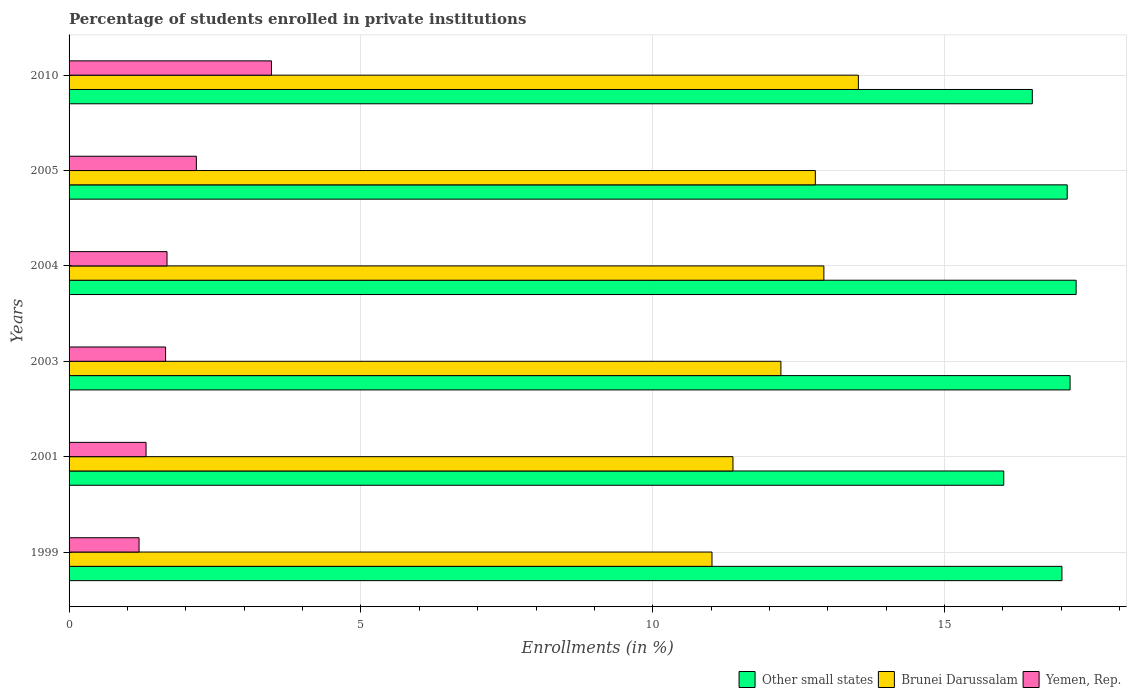How many groups of bars are there?
Your answer should be compact. 6. How many bars are there on the 4th tick from the top?
Keep it short and to the point. 3. How many bars are there on the 5th tick from the bottom?
Offer a terse response. 3. What is the label of the 1st group of bars from the top?
Offer a terse response. 2010. What is the percentage of trained teachers in Brunei Darussalam in 2005?
Provide a succinct answer. 12.79. Across all years, what is the maximum percentage of trained teachers in Other small states?
Provide a short and direct response. 17.25. Across all years, what is the minimum percentage of trained teachers in Brunei Darussalam?
Make the answer very short. 11.01. In which year was the percentage of trained teachers in Yemen, Rep. minimum?
Give a very brief answer. 1999. What is the total percentage of trained teachers in Brunei Darussalam in the graph?
Make the answer very short. 73.83. What is the difference between the percentage of trained teachers in Brunei Darussalam in 1999 and that in 2003?
Offer a terse response. -1.18. What is the difference between the percentage of trained teachers in Other small states in 1999 and the percentage of trained teachers in Brunei Darussalam in 2003?
Your answer should be very brief. 4.81. What is the average percentage of trained teachers in Yemen, Rep. per year?
Provide a succinct answer. 1.92. In the year 2010, what is the difference between the percentage of trained teachers in Yemen, Rep. and percentage of trained teachers in Other small states?
Provide a succinct answer. -13.04. What is the ratio of the percentage of trained teachers in Brunei Darussalam in 2001 to that in 2003?
Give a very brief answer. 0.93. Is the percentage of trained teachers in Other small states in 1999 less than that in 2003?
Offer a very short reply. Yes. Is the difference between the percentage of trained teachers in Yemen, Rep. in 2003 and 2005 greater than the difference between the percentage of trained teachers in Other small states in 2003 and 2005?
Make the answer very short. No. What is the difference between the highest and the second highest percentage of trained teachers in Brunei Darussalam?
Give a very brief answer. 0.59. What is the difference between the highest and the lowest percentage of trained teachers in Yemen, Rep.?
Ensure brevity in your answer.  2.27. In how many years, is the percentage of trained teachers in Yemen, Rep. greater than the average percentage of trained teachers in Yemen, Rep. taken over all years?
Offer a terse response. 2. What does the 1st bar from the top in 1999 represents?
Provide a succinct answer. Yemen, Rep. What does the 3rd bar from the bottom in 1999 represents?
Give a very brief answer. Yemen, Rep. How many bars are there?
Your answer should be compact. 18. What is the difference between two consecutive major ticks on the X-axis?
Provide a short and direct response. 5. Does the graph contain any zero values?
Provide a succinct answer. No. How are the legend labels stacked?
Your answer should be very brief. Horizontal. What is the title of the graph?
Ensure brevity in your answer.  Percentage of students enrolled in private institutions. What is the label or title of the X-axis?
Ensure brevity in your answer.  Enrollments (in %). What is the label or title of the Y-axis?
Make the answer very short. Years. What is the Enrollments (in %) in Other small states in 1999?
Your response must be concise. 17.01. What is the Enrollments (in %) in Brunei Darussalam in 1999?
Ensure brevity in your answer.  11.01. What is the Enrollments (in %) in Yemen, Rep. in 1999?
Offer a very short reply. 1.2. What is the Enrollments (in %) of Other small states in 2001?
Give a very brief answer. 16.01. What is the Enrollments (in %) of Brunei Darussalam in 2001?
Your answer should be very brief. 11.37. What is the Enrollments (in %) in Yemen, Rep. in 2001?
Give a very brief answer. 1.32. What is the Enrollments (in %) of Other small states in 2003?
Your response must be concise. 17.15. What is the Enrollments (in %) of Brunei Darussalam in 2003?
Offer a very short reply. 12.2. What is the Enrollments (in %) of Yemen, Rep. in 2003?
Offer a very short reply. 1.65. What is the Enrollments (in %) of Other small states in 2004?
Offer a very short reply. 17.25. What is the Enrollments (in %) in Brunei Darussalam in 2004?
Offer a very short reply. 12.93. What is the Enrollments (in %) in Yemen, Rep. in 2004?
Your response must be concise. 1.68. What is the Enrollments (in %) in Other small states in 2005?
Offer a terse response. 17.1. What is the Enrollments (in %) in Brunei Darussalam in 2005?
Offer a very short reply. 12.79. What is the Enrollments (in %) of Yemen, Rep. in 2005?
Make the answer very short. 2.18. What is the Enrollments (in %) in Other small states in 2010?
Provide a succinct answer. 16.5. What is the Enrollments (in %) of Brunei Darussalam in 2010?
Provide a short and direct response. 13.52. What is the Enrollments (in %) in Yemen, Rep. in 2010?
Your answer should be compact. 3.47. Across all years, what is the maximum Enrollments (in %) of Other small states?
Provide a succinct answer. 17.25. Across all years, what is the maximum Enrollments (in %) in Brunei Darussalam?
Keep it short and to the point. 13.52. Across all years, what is the maximum Enrollments (in %) of Yemen, Rep.?
Offer a terse response. 3.47. Across all years, what is the minimum Enrollments (in %) in Other small states?
Keep it short and to the point. 16.01. Across all years, what is the minimum Enrollments (in %) of Brunei Darussalam?
Your response must be concise. 11.01. Across all years, what is the minimum Enrollments (in %) in Yemen, Rep.?
Your answer should be very brief. 1.2. What is the total Enrollments (in %) of Other small states in the graph?
Offer a very short reply. 101.03. What is the total Enrollments (in %) in Brunei Darussalam in the graph?
Ensure brevity in your answer.  73.83. What is the total Enrollments (in %) in Yemen, Rep. in the graph?
Provide a succinct answer. 11.5. What is the difference between the Enrollments (in %) in Brunei Darussalam in 1999 and that in 2001?
Provide a short and direct response. -0.36. What is the difference between the Enrollments (in %) of Yemen, Rep. in 1999 and that in 2001?
Ensure brevity in your answer.  -0.12. What is the difference between the Enrollments (in %) of Other small states in 1999 and that in 2003?
Keep it short and to the point. -0.14. What is the difference between the Enrollments (in %) in Brunei Darussalam in 1999 and that in 2003?
Offer a terse response. -1.18. What is the difference between the Enrollments (in %) of Yemen, Rep. in 1999 and that in 2003?
Provide a succinct answer. -0.45. What is the difference between the Enrollments (in %) of Other small states in 1999 and that in 2004?
Your answer should be compact. -0.24. What is the difference between the Enrollments (in %) in Brunei Darussalam in 1999 and that in 2004?
Offer a terse response. -1.92. What is the difference between the Enrollments (in %) of Yemen, Rep. in 1999 and that in 2004?
Give a very brief answer. -0.48. What is the difference between the Enrollments (in %) in Other small states in 1999 and that in 2005?
Ensure brevity in your answer.  -0.09. What is the difference between the Enrollments (in %) in Brunei Darussalam in 1999 and that in 2005?
Ensure brevity in your answer.  -1.77. What is the difference between the Enrollments (in %) in Yemen, Rep. in 1999 and that in 2005?
Give a very brief answer. -0.98. What is the difference between the Enrollments (in %) in Other small states in 1999 and that in 2010?
Give a very brief answer. 0.51. What is the difference between the Enrollments (in %) of Brunei Darussalam in 1999 and that in 2010?
Give a very brief answer. -2.51. What is the difference between the Enrollments (in %) of Yemen, Rep. in 1999 and that in 2010?
Offer a very short reply. -2.27. What is the difference between the Enrollments (in %) of Other small states in 2001 and that in 2003?
Keep it short and to the point. -1.14. What is the difference between the Enrollments (in %) in Brunei Darussalam in 2001 and that in 2003?
Offer a very short reply. -0.82. What is the difference between the Enrollments (in %) in Yemen, Rep. in 2001 and that in 2003?
Your answer should be very brief. -0.33. What is the difference between the Enrollments (in %) in Other small states in 2001 and that in 2004?
Ensure brevity in your answer.  -1.24. What is the difference between the Enrollments (in %) in Brunei Darussalam in 2001 and that in 2004?
Offer a very short reply. -1.56. What is the difference between the Enrollments (in %) of Yemen, Rep. in 2001 and that in 2004?
Make the answer very short. -0.36. What is the difference between the Enrollments (in %) of Other small states in 2001 and that in 2005?
Your answer should be compact. -1.09. What is the difference between the Enrollments (in %) in Brunei Darussalam in 2001 and that in 2005?
Make the answer very short. -1.41. What is the difference between the Enrollments (in %) in Yemen, Rep. in 2001 and that in 2005?
Offer a very short reply. -0.86. What is the difference between the Enrollments (in %) of Other small states in 2001 and that in 2010?
Offer a very short reply. -0.49. What is the difference between the Enrollments (in %) of Brunei Darussalam in 2001 and that in 2010?
Ensure brevity in your answer.  -2.15. What is the difference between the Enrollments (in %) of Yemen, Rep. in 2001 and that in 2010?
Your response must be concise. -2.15. What is the difference between the Enrollments (in %) of Other small states in 2003 and that in 2004?
Provide a succinct answer. -0.1. What is the difference between the Enrollments (in %) in Brunei Darussalam in 2003 and that in 2004?
Your response must be concise. -0.74. What is the difference between the Enrollments (in %) of Yemen, Rep. in 2003 and that in 2004?
Offer a terse response. -0.02. What is the difference between the Enrollments (in %) of Other small states in 2003 and that in 2005?
Provide a short and direct response. 0.05. What is the difference between the Enrollments (in %) of Brunei Darussalam in 2003 and that in 2005?
Your answer should be compact. -0.59. What is the difference between the Enrollments (in %) of Yemen, Rep. in 2003 and that in 2005?
Offer a terse response. -0.53. What is the difference between the Enrollments (in %) in Other small states in 2003 and that in 2010?
Offer a terse response. 0.65. What is the difference between the Enrollments (in %) in Brunei Darussalam in 2003 and that in 2010?
Your response must be concise. -1.33. What is the difference between the Enrollments (in %) in Yemen, Rep. in 2003 and that in 2010?
Give a very brief answer. -1.81. What is the difference between the Enrollments (in %) of Other small states in 2004 and that in 2005?
Offer a terse response. 0.15. What is the difference between the Enrollments (in %) of Brunei Darussalam in 2004 and that in 2005?
Make the answer very short. 0.15. What is the difference between the Enrollments (in %) of Yemen, Rep. in 2004 and that in 2005?
Your response must be concise. -0.5. What is the difference between the Enrollments (in %) in Other small states in 2004 and that in 2010?
Your answer should be compact. 0.75. What is the difference between the Enrollments (in %) in Brunei Darussalam in 2004 and that in 2010?
Keep it short and to the point. -0.59. What is the difference between the Enrollments (in %) in Yemen, Rep. in 2004 and that in 2010?
Keep it short and to the point. -1.79. What is the difference between the Enrollments (in %) in Other small states in 2005 and that in 2010?
Offer a terse response. 0.6. What is the difference between the Enrollments (in %) of Brunei Darussalam in 2005 and that in 2010?
Make the answer very short. -0.74. What is the difference between the Enrollments (in %) of Yemen, Rep. in 2005 and that in 2010?
Your answer should be very brief. -1.29. What is the difference between the Enrollments (in %) in Other small states in 1999 and the Enrollments (in %) in Brunei Darussalam in 2001?
Your response must be concise. 5.64. What is the difference between the Enrollments (in %) in Other small states in 1999 and the Enrollments (in %) in Yemen, Rep. in 2001?
Ensure brevity in your answer.  15.69. What is the difference between the Enrollments (in %) of Brunei Darussalam in 1999 and the Enrollments (in %) of Yemen, Rep. in 2001?
Make the answer very short. 9.7. What is the difference between the Enrollments (in %) of Other small states in 1999 and the Enrollments (in %) of Brunei Darussalam in 2003?
Your answer should be very brief. 4.81. What is the difference between the Enrollments (in %) in Other small states in 1999 and the Enrollments (in %) in Yemen, Rep. in 2003?
Offer a very short reply. 15.36. What is the difference between the Enrollments (in %) of Brunei Darussalam in 1999 and the Enrollments (in %) of Yemen, Rep. in 2003?
Your answer should be very brief. 9.36. What is the difference between the Enrollments (in %) of Other small states in 1999 and the Enrollments (in %) of Brunei Darussalam in 2004?
Provide a succinct answer. 4.08. What is the difference between the Enrollments (in %) of Other small states in 1999 and the Enrollments (in %) of Yemen, Rep. in 2004?
Provide a short and direct response. 15.33. What is the difference between the Enrollments (in %) of Brunei Darussalam in 1999 and the Enrollments (in %) of Yemen, Rep. in 2004?
Offer a very short reply. 9.34. What is the difference between the Enrollments (in %) in Other small states in 1999 and the Enrollments (in %) in Brunei Darussalam in 2005?
Offer a terse response. 4.22. What is the difference between the Enrollments (in %) in Other small states in 1999 and the Enrollments (in %) in Yemen, Rep. in 2005?
Your response must be concise. 14.83. What is the difference between the Enrollments (in %) in Brunei Darussalam in 1999 and the Enrollments (in %) in Yemen, Rep. in 2005?
Provide a short and direct response. 8.83. What is the difference between the Enrollments (in %) of Other small states in 1999 and the Enrollments (in %) of Brunei Darussalam in 2010?
Offer a very short reply. 3.49. What is the difference between the Enrollments (in %) of Other small states in 1999 and the Enrollments (in %) of Yemen, Rep. in 2010?
Offer a very short reply. 13.54. What is the difference between the Enrollments (in %) of Brunei Darussalam in 1999 and the Enrollments (in %) of Yemen, Rep. in 2010?
Provide a succinct answer. 7.55. What is the difference between the Enrollments (in %) in Other small states in 2001 and the Enrollments (in %) in Brunei Darussalam in 2003?
Give a very brief answer. 3.82. What is the difference between the Enrollments (in %) in Other small states in 2001 and the Enrollments (in %) in Yemen, Rep. in 2003?
Make the answer very short. 14.36. What is the difference between the Enrollments (in %) in Brunei Darussalam in 2001 and the Enrollments (in %) in Yemen, Rep. in 2003?
Your response must be concise. 9.72. What is the difference between the Enrollments (in %) of Other small states in 2001 and the Enrollments (in %) of Brunei Darussalam in 2004?
Your answer should be compact. 3.08. What is the difference between the Enrollments (in %) in Other small states in 2001 and the Enrollments (in %) in Yemen, Rep. in 2004?
Your answer should be compact. 14.34. What is the difference between the Enrollments (in %) in Brunei Darussalam in 2001 and the Enrollments (in %) in Yemen, Rep. in 2004?
Offer a terse response. 9.7. What is the difference between the Enrollments (in %) of Other small states in 2001 and the Enrollments (in %) of Brunei Darussalam in 2005?
Your answer should be very brief. 3.23. What is the difference between the Enrollments (in %) in Other small states in 2001 and the Enrollments (in %) in Yemen, Rep. in 2005?
Your answer should be compact. 13.83. What is the difference between the Enrollments (in %) in Brunei Darussalam in 2001 and the Enrollments (in %) in Yemen, Rep. in 2005?
Offer a terse response. 9.19. What is the difference between the Enrollments (in %) in Other small states in 2001 and the Enrollments (in %) in Brunei Darussalam in 2010?
Your response must be concise. 2.49. What is the difference between the Enrollments (in %) in Other small states in 2001 and the Enrollments (in %) in Yemen, Rep. in 2010?
Offer a terse response. 12.55. What is the difference between the Enrollments (in %) of Brunei Darussalam in 2001 and the Enrollments (in %) of Yemen, Rep. in 2010?
Your response must be concise. 7.91. What is the difference between the Enrollments (in %) in Other small states in 2003 and the Enrollments (in %) in Brunei Darussalam in 2004?
Provide a succinct answer. 4.22. What is the difference between the Enrollments (in %) in Other small states in 2003 and the Enrollments (in %) in Yemen, Rep. in 2004?
Offer a terse response. 15.47. What is the difference between the Enrollments (in %) in Brunei Darussalam in 2003 and the Enrollments (in %) in Yemen, Rep. in 2004?
Make the answer very short. 10.52. What is the difference between the Enrollments (in %) in Other small states in 2003 and the Enrollments (in %) in Brunei Darussalam in 2005?
Give a very brief answer. 4.36. What is the difference between the Enrollments (in %) in Other small states in 2003 and the Enrollments (in %) in Yemen, Rep. in 2005?
Offer a terse response. 14.97. What is the difference between the Enrollments (in %) of Brunei Darussalam in 2003 and the Enrollments (in %) of Yemen, Rep. in 2005?
Provide a short and direct response. 10.01. What is the difference between the Enrollments (in %) in Other small states in 2003 and the Enrollments (in %) in Brunei Darussalam in 2010?
Ensure brevity in your answer.  3.63. What is the difference between the Enrollments (in %) of Other small states in 2003 and the Enrollments (in %) of Yemen, Rep. in 2010?
Offer a terse response. 13.68. What is the difference between the Enrollments (in %) in Brunei Darussalam in 2003 and the Enrollments (in %) in Yemen, Rep. in 2010?
Keep it short and to the point. 8.73. What is the difference between the Enrollments (in %) of Other small states in 2004 and the Enrollments (in %) of Brunei Darussalam in 2005?
Offer a very short reply. 4.47. What is the difference between the Enrollments (in %) of Other small states in 2004 and the Enrollments (in %) of Yemen, Rep. in 2005?
Make the answer very short. 15.07. What is the difference between the Enrollments (in %) in Brunei Darussalam in 2004 and the Enrollments (in %) in Yemen, Rep. in 2005?
Offer a terse response. 10.75. What is the difference between the Enrollments (in %) of Other small states in 2004 and the Enrollments (in %) of Brunei Darussalam in 2010?
Keep it short and to the point. 3.73. What is the difference between the Enrollments (in %) in Other small states in 2004 and the Enrollments (in %) in Yemen, Rep. in 2010?
Your answer should be compact. 13.79. What is the difference between the Enrollments (in %) in Brunei Darussalam in 2004 and the Enrollments (in %) in Yemen, Rep. in 2010?
Give a very brief answer. 9.46. What is the difference between the Enrollments (in %) in Other small states in 2005 and the Enrollments (in %) in Brunei Darussalam in 2010?
Give a very brief answer. 3.58. What is the difference between the Enrollments (in %) of Other small states in 2005 and the Enrollments (in %) of Yemen, Rep. in 2010?
Your response must be concise. 13.63. What is the difference between the Enrollments (in %) in Brunei Darussalam in 2005 and the Enrollments (in %) in Yemen, Rep. in 2010?
Keep it short and to the point. 9.32. What is the average Enrollments (in %) of Other small states per year?
Ensure brevity in your answer.  16.84. What is the average Enrollments (in %) of Brunei Darussalam per year?
Offer a terse response. 12.3. What is the average Enrollments (in %) in Yemen, Rep. per year?
Offer a terse response. 1.92. In the year 1999, what is the difference between the Enrollments (in %) in Other small states and Enrollments (in %) in Brunei Darussalam?
Offer a very short reply. 6. In the year 1999, what is the difference between the Enrollments (in %) of Other small states and Enrollments (in %) of Yemen, Rep.?
Offer a very short reply. 15.81. In the year 1999, what is the difference between the Enrollments (in %) of Brunei Darussalam and Enrollments (in %) of Yemen, Rep.?
Provide a succinct answer. 9.82. In the year 2001, what is the difference between the Enrollments (in %) in Other small states and Enrollments (in %) in Brunei Darussalam?
Your answer should be compact. 4.64. In the year 2001, what is the difference between the Enrollments (in %) in Other small states and Enrollments (in %) in Yemen, Rep.?
Make the answer very short. 14.69. In the year 2001, what is the difference between the Enrollments (in %) of Brunei Darussalam and Enrollments (in %) of Yemen, Rep.?
Offer a terse response. 10.06. In the year 2003, what is the difference between the Enrollments (in %) of Other small states and Enrollments (in %) of Brunei Darussalam?
Ensure brevity in your answer.  4.95. In the year 2003, what is the difference between the Enrollments (in %) in Other small states and Enrollments (in %) in Yemen, Rep.?
Keep it short and to the point. 15.5. In the year 2003, what is the difference between the Enrollments (in %) in Brunei Darussalam and Enrollments (in %) in Yemen, Rep.?
Ensure brevity in your answer.  10.54. In the year 2004, what is the difference between the Enrollments (in %) in Other small states and Enrollments (in %) in Brunei Darussalam?
Keep it short and to the point. 4.32. In the year 2004, what is the difference between the Enrollments (in %) in Other small states and Enrollments (in %) in Yemen, Rep.?
Ensure brevity in your answer.  15.58. In the year 2004, what is the difference between the Enrollments (in %) of Brunei Darussalam and Enrollments (in %) of Yemen, Rep.?
Provide a short and direct response. 11.25. In the year 2005, what is the difference between the Enrollments (in %) of Other small states and Enrollments (in %) of Brunei Darussalam?
Your response must be concise. 4.32. In the year 2005, what is the difference between the Enrollments (in %) in Other small states and Enrollments (in %) in Yemen, Rep.?
Your answer should be very brief. 14.92. In the year 2005, what is the difference between the Enrollments (in %) in Brunei Darussalam and Enrollments (in %) in Yemen, Rep.?
Provide a short and direct response. 10.6. In the year 2010, what is the difference between the Enrollments (in %) of Other small states and Enrollments (in %) of Brunei Darussalam?
Your answer should be compact. 2.98. In the year 2010, what is the difference between the Enrollments (in %) in Other small states and Enrollments (in %) in Yemen, Rep.?
Your answer should be very brief. 13.04. In the year 2010, what is the difference between the Enrollments (in %) of Brunei Darussalam and Enrollments (in %) of Yemen, Rep.?
Offer a terse response. 10.06. What is the ratio of the Enrollments (in %) of Other small states in 1999 to that in 2001?
Provide a succinct answer. 1.06. What is the ratio of the Enrollments (in %) of Brunei Darussalam in 1999 to that in 2001?
Provide a succinct answer. 0.97. What is the ratio of the Enrollments (in %) of Yemen, Rep. in 1999 to that in 2001?
Your response must be concise. 0.91. What is the ratio of the Enrollments (in %) in Brunei Darussalam in 1999 to that in 2003?
Your answer should be very brief. 0.9. What is the ratio of the Enrollments (in %) of Yemen, Rep. in 1999 to that in 2003?
Provide a short and direct response. 0.72. What is the ratio of the Enrollments (in %) in Other small states in 1999 to that in 2004?
Provide a succinct answer. 0.99. What is the ratio of the Enrollments (in %) of Brunei Darussalam in 1999 to that in 2004?
Keep it short and to the point. 0.85. What is the ratio of the Enrollments (in %) in Yemen, Rep. in 1999 to that in 2004?
Provide a succinct answer. 0.71. What is the ratio of the Enrollments (in %) in Other small states in 1999 to that in 2005?
Make the answer very short. 0.99. What is the ratio of the Enrollments (in %) in Brunei Darussalam in 1999 to that in 2005?
Your answer should be very brief. 0.86. What is the ratio of the Enrollments (in %) of Yemen, Rep. in 1999 to that in 2005?
Ensure brevity in your answer.  0.55. What is the ratio of the Enrollments (in %) in Other small states in 1999 to that in 2010?
Your answer should be compact. 1.03. What is the ratio of the Enrollments (in %) of Brunei Darussalam in 1999 to that in 2010?
Your answer should be compact. 0.81. What is the ratio of the Enrollments (in %) in Yemen, Rep. in 1999 to that in 2010?
Ensure brevity in your answer.  0.35. What is the ratio of the Enrollments (in %) of Other small states in 2001 to that in 2003?
Offer a terse response. 0.93. What is the ratio of the Enrollments (in %) in Brunei Darussalam in 2001 to that in 2003?
Make the answer very short. 0.93. What is the ratio of the Enrollments (in %) in Yemen, Rep. in 2001 to that in 2003?
Ensure brevity in your answer.  0.8. What is the ratio of the Enrollments (in %) of Other small states in 2001 to that in 2004?
Your answer should be very brief. 0.93. What is the ratio of the Enrollments (in %) in Brunei Darussalam in 2001 to that in 2004?
Give a very brief answer. 0.88. What is the ratio of the Enrollments (in %) in Yemen, Rep. in 2001 to that in 2004?
Your answer should be very brief. 0.79. What is the ratio of the Enrollments (in %) of Other small states in 2001 to that in 2005?
Ensure brevity in your answer.  0.94. What is the ratio of the Enrollments (in %) in Brunei Darussalam in 2001 to that in 2005?
Keep it short and to the point. 0.89. What is the ratio of the Enrollments (in %) of Yemen, Rep. in 2001 to that in 2005?
Give a very brief answer. 0.6. What is the ratio of the Enrollments (in %) of Other small states in 2001 to that in 2010?
Offer a terse response. 0.97. What is the ratio of the Enrollments (in %) in Brunei Darussalam in 2001 to that in 2010?
Offer a very short reply. 0.84. What is the ratio of the Enrollments (in %) of Yemen, Rep. in 2001 to that in 2010?
Keep it short and to the point. 0.38. What is the ratio of the Enrollments (in %) of Brunei Darussalam in 2003 to that in 2004?
Offer a terse response. 0.94. What is the ratio of the Enrollments (in %) in Yemen, Rep. in 2003 to that in 2004?
Offer a very short reply. 0.99. What is the ratio of the Enrollments (in %) of Other small states in 2003 to that in 2005?
Offer a terse response. 1. What is the ratio of the Enrollments (in %) of Brunei Darussalam in 2003 to that in 2005?
Provide a succinct answer. 0.95. What is the ratio of the Enrollments (in %) in Yemen, Rep. in 2003 to that in 2005?
Your answer should be very brief. 0.76. What is the ratio of the Enrollments (in %) of Other small states in 2003 to that in 2010?
Provide a succinct answer. 1.04. What is the ratio of the Enrollments (in %) in Brunei Darussalam in 2003 to that in 2010?
Your answer should be very brief. 0.9. What is the ratio of the Enrollments (in %) in Yemen, Rep. in 2003 to that in 2010?
Your response must be concise. 0.48. What is the ratio of the Enrollments (in %) in Other small states in 2004 to that in 2005?
Give a very brief answer. 1.01. What is the ratio of the Enrollments (in %) in Brunei Darussalam in 2004 to that in 2005?
Your answer should be compact. 1.01. What is the ratio of the Enrollments (in %) of Yemen, Rep. in 2004 to that in 2005?
Offer a terse response. 0.77. What is the ratio of the Enrollments (in %) of Other small states in 2004 to that in 2010?
Offer a terse response. 1.05. What is the ratio of the Enrollments (in %) in Brunei Darussalam in 2004 to that in 2010?
Your answer should be compact. 0.96. What is the ratio of the Enrollments (in %) of Yemen, Rep. in 2004 to that in 2010?
Give a very brief answer. 0.48. What is the ratio of the Enrollments (in %) of Other small states in 2005 to that in 2010?
Your answer should be compact. 1.04. What is the ratio of the Enrollments (in %) in Brunei Darussalam in 2005 to that in 2010?
Offer a terse response. 0.95. What is the ratio of the Enrollments (in %) in Yemen, Rep. in 2005 to that in 2010?
Your answer should be compact. 0.63. What is the difference between the highest and the second highest Enrollments (in %) in Other small states?
Make the answer very short. 0.1. What is the difference between the highest and the second highest Enrollments (in %) of Brunei Darussalam?
Your answer should be compact. 0.59. What is the difference between the highest and the second highest Enrollments (in %) in Yemen, Rep.?
Your answer should be compact. 1.29. What is the difference between the highest and the lowest Enrollments (in %) in Other small states?
Offer a very short reply. 1.24. What is the difference between the highest and the lowest Enrollments (in %) of Brunei Darussalam?
Provide a succinct answer. 2.51. What is the difference between the highest and the lowest Enrollments (in %) of Yemen, Rep.?
Provide a succinct answer. 2.27. 